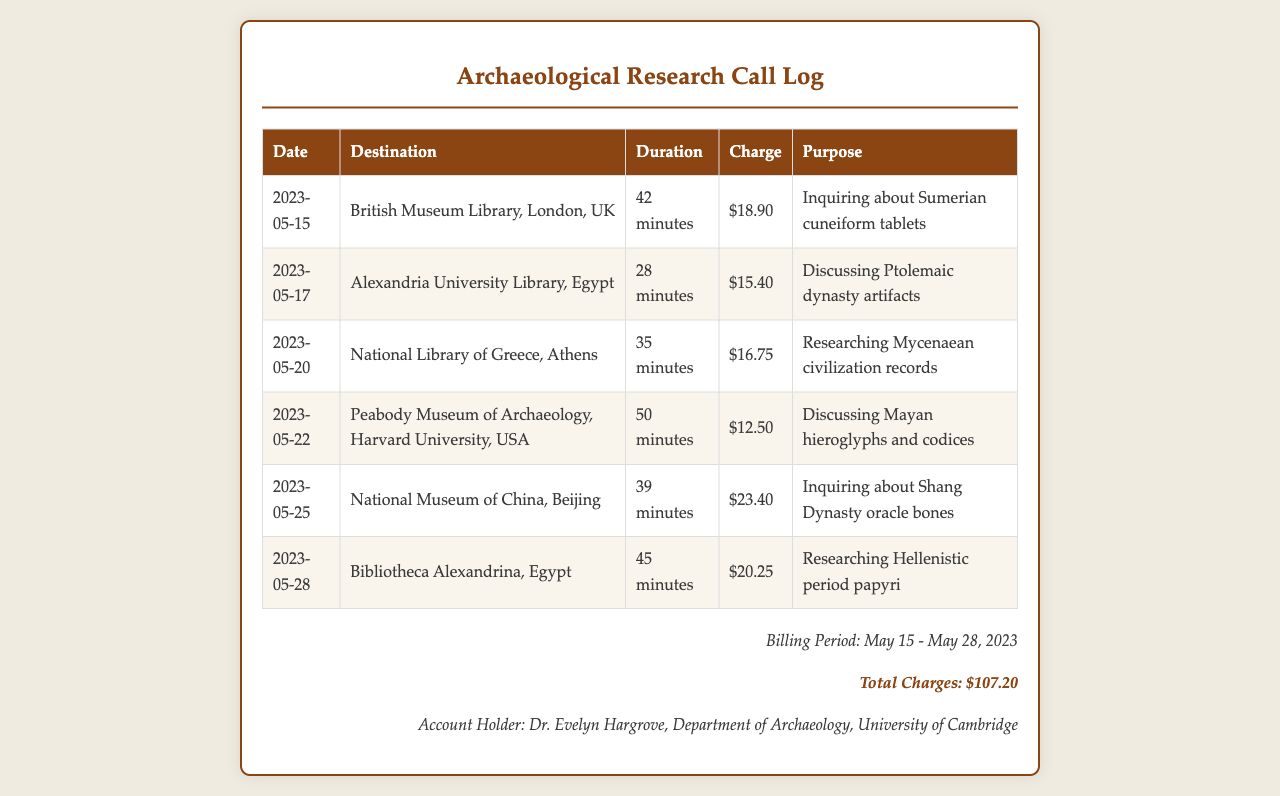What is the total charge? The total charge summarizes all individual call charges listed in the document, which adds up to $107.20.
Answer: $107.20 Who is the account holder? The document identifies the account holder in the billing section, which lists Dr. Evelyn Hargrove.
Answer: Dr. Evelyn Hargrove What was the duration of the call to the National Library of Greece? The duration for that specific call can be found in the table, indicating 35 minutes.
Answer: 35 minutes Which institution was contacted on May 20? The date corresponds to a specific entry in the call log, which is the National Library of Greece.
Answer: National Library of Greece What was the charge for the call to the British Museum Library? The charge for that call is specified directly in the table, showing $18.90.
Answer: $18.90 What is the purpose of the call to the National Museum of China? The document provides a description for each call, and for this one, it was inquiring about Shang Dynasty oracle bones.
Answer: Inquiring about Shang Dynasty oracle bones Which library's call lasted the longest? By comparing durations in the table, the call to the Peabody Museum lasted the longest at 50 minutes.
Answer: Peabody Museum of Archaeology How many calls were made during the billing period? The number of entries in the table indicates that there were six calls made during the specified billing period.
Answer: 6 calls What is the date of the last recorded call in the document? The last entry in the table reveals that the last recorded call was made on May 28, 2023.
Answer: May 28, 2023 